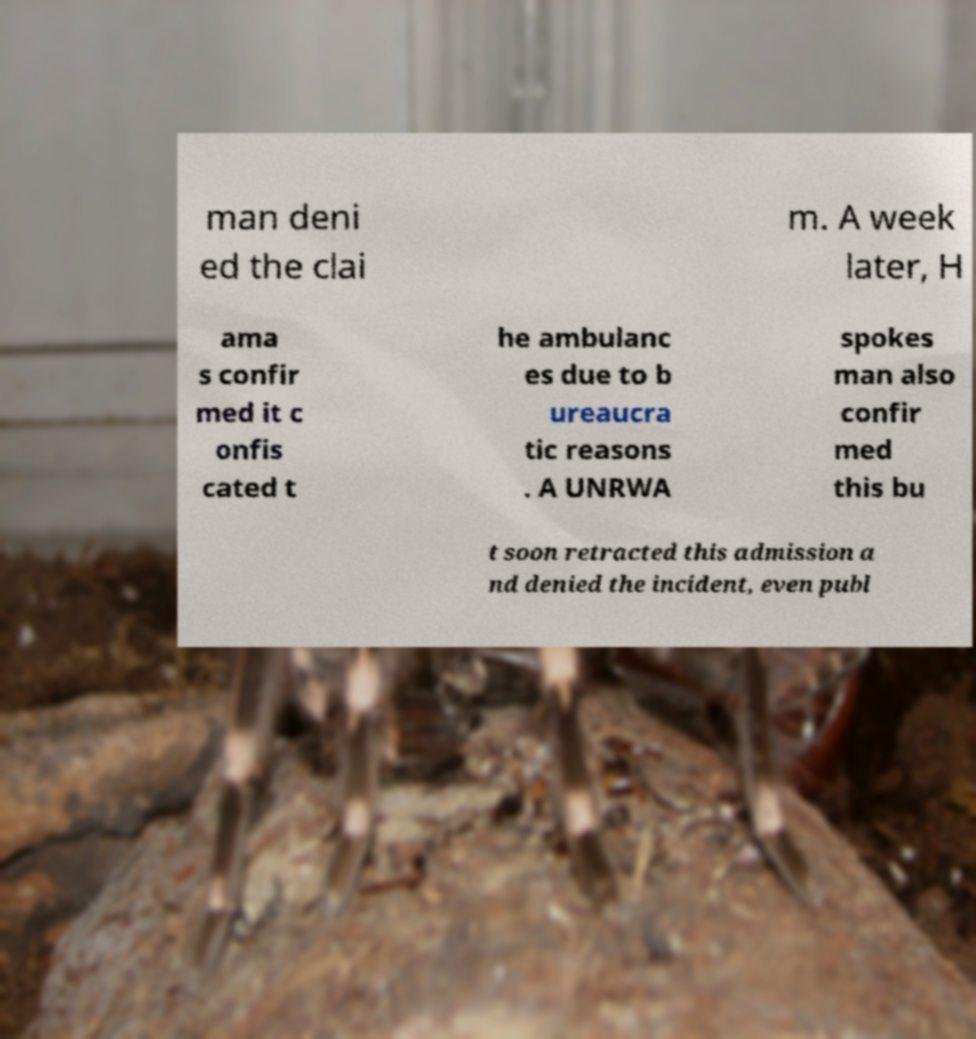For documentation purposes, I need the text within this image transcribed. Could you provide that? man deni ed the clai m. A week later, H ama s confir med it c onfis cated t he ambulanc es due to b ureaucra tic reasons . A UNRWA spokes man also confir med this bu t soon retracted this admission a nd denied the incident, even publ 